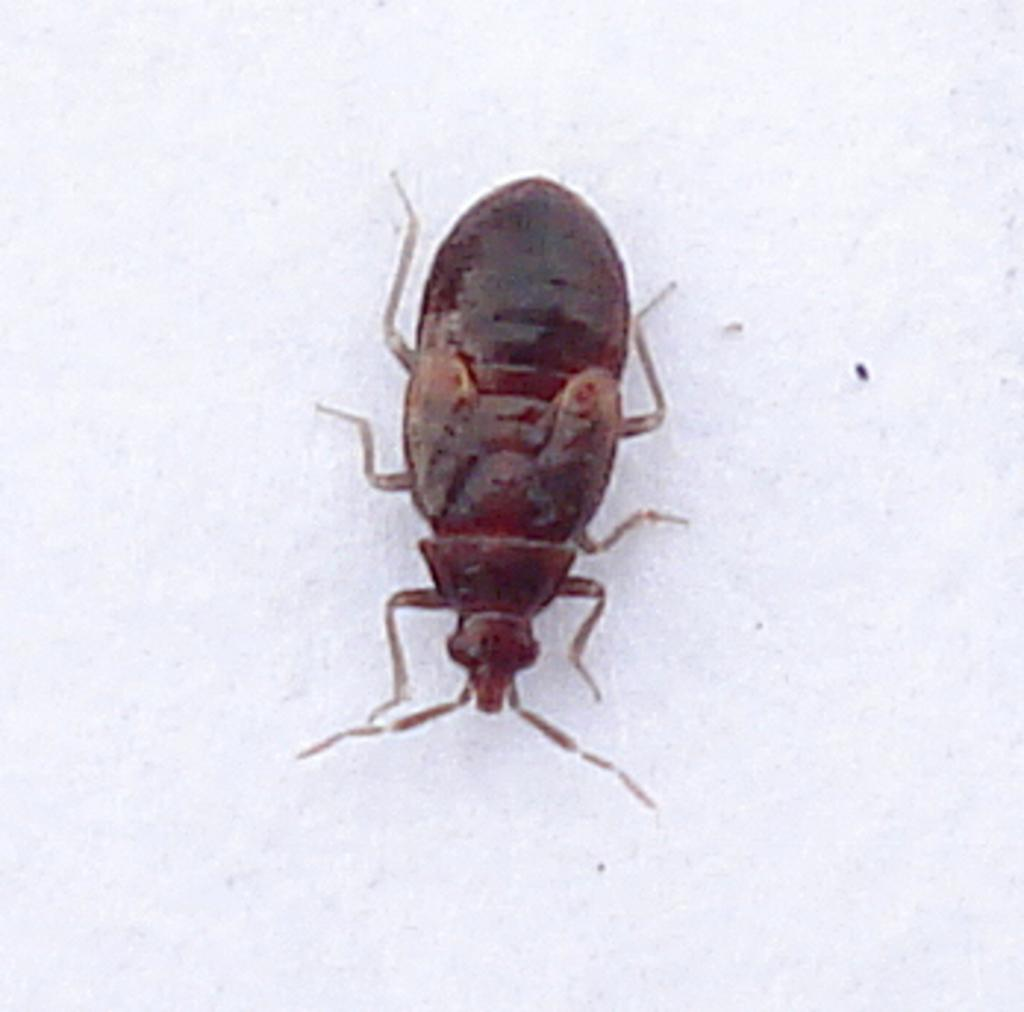What is the color of the main object in the image? The main object in the image is white. What is present on the white object? There is a brown cockroach on the white object. What type of development can be seen in the image? There is no development or construction project visible in the image; it features a white object with a brown cockroach on it. Can you see a plane flying in the image? There is no plane visible in the image. Is there a deer present in the image? There is no deer present in the image. 